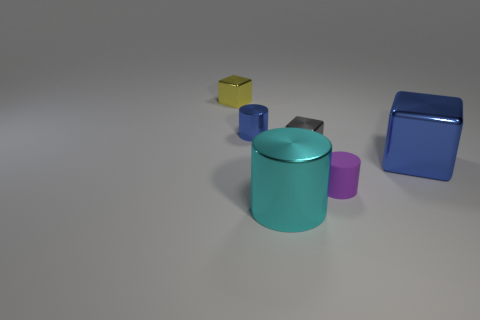What is the size of the blue object that is the same shape as the tiny gray object?
Make the answer very short. Large. There is a large metal thing that is the same shape as the tiny yellow metallic object; what color is it?
Provide a succinct answer. Blue. Is the material of the tiny purple cylinder the same as the tiny block that is in front of the small blue thing?
Make the answer very short. No. What number of small blue things have the same material as the purple cylinder?
Give a very brief answer. 0. There is a large thing to the left of the blue cube; what shape is it?
Ensure brevity in your answer.  Cylinder. Are the small cylinder that is on the left side of the small purple matte object and the tiny cube that is in front of the tiny blue object made of the same material?
Your response must be concise. Yes. Is there a small rubber object of the same shape as the big blue thing?
Your answer should be compact. No. How many objects are metal cubes behind the large shiny cube or large cyan shiny cylinders?
Provide a short and direct response. 3. Is the number of purple things left of the gray metallic thing greater than the number of blue objects to the right of the big blue thing?
Ensure brevity in your answer.  No. How many metal things are either gray blocks or big blue cubes?
Provide a succinct answer. 2. 